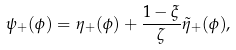<formula> <loc_0><loc_0><loc_500><loc_500>\psi _ { + } ( \phi ) = \eta _ { + } ( \phi ) + \frac { 1 - \xi } { \zeta } \tilde { \eta } _ { + } ( \phi ) ,</formula> 